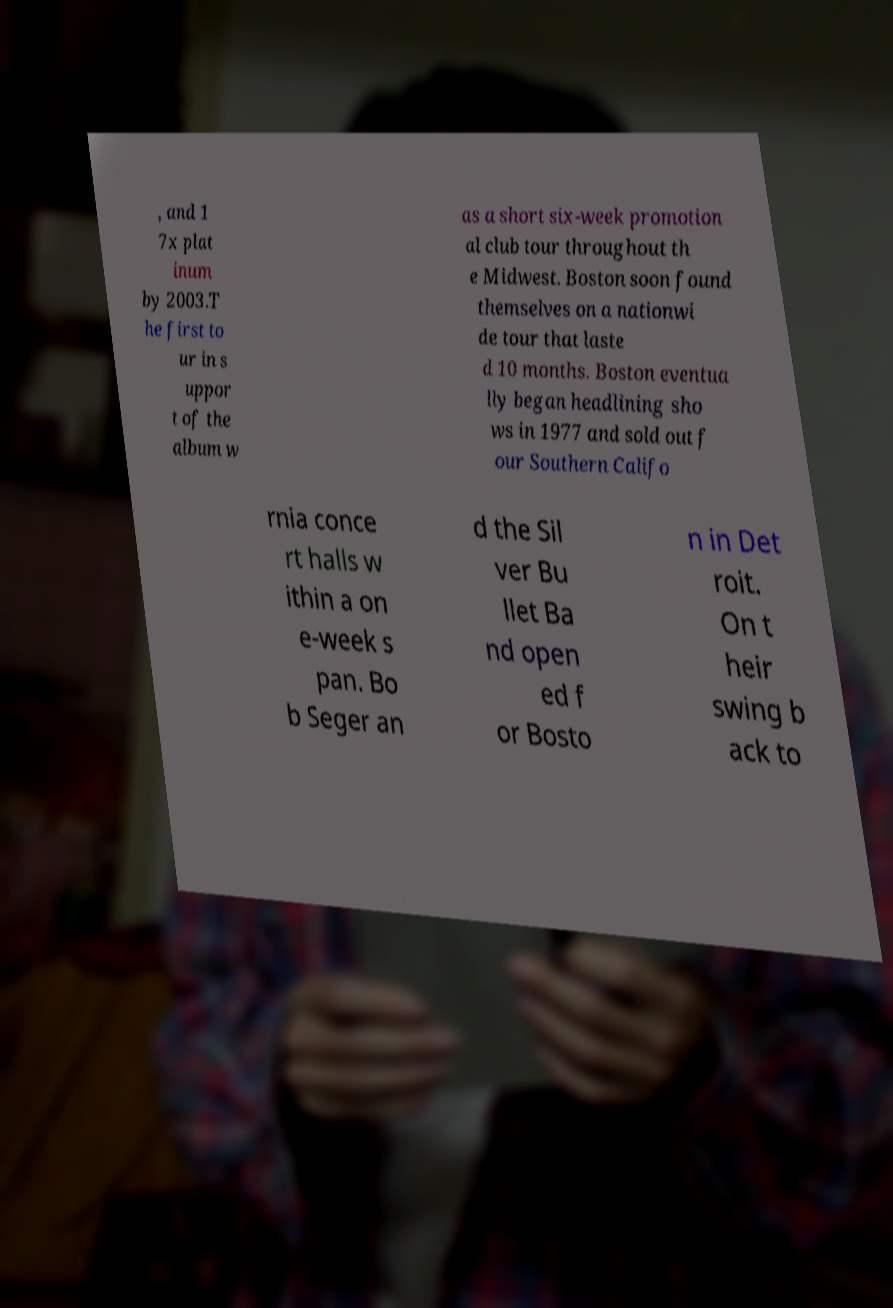There's text embedded in this image that I need extracted. Can you transcribe it verbatim? , and 1 7x plat inum by 2003.T he first to ur in s uppor t of the album w as a short six-week promotion al club tour throughout th e Midwest. Boston soon found themselves on a nationwi de tour that laste d 10 months. Boston eventua lly began headlining sho ws in 1977 and sold out f our Southern Califo rnia conce rt halls w ithin a on e-week s pan. Bo b Seger an d the Sil ver Bu llet Ba nd open ed f or Bosto n in Det roit. On t heir swing b ack to 